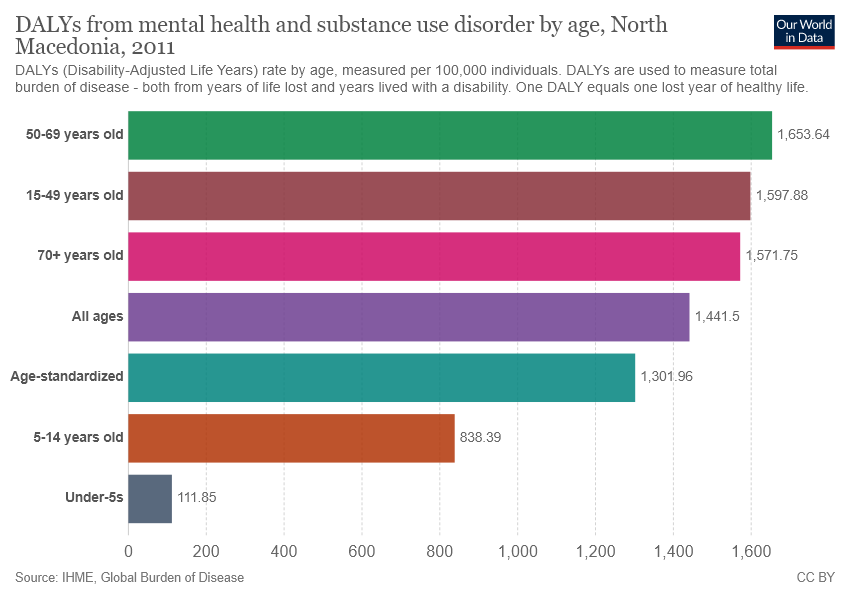Give some essential details in this illustration. The largest segment has a value of 1653.64. The sum of the smallest bar and the largest bar is 1765.49 and this is the new height of the Pareto chart. 